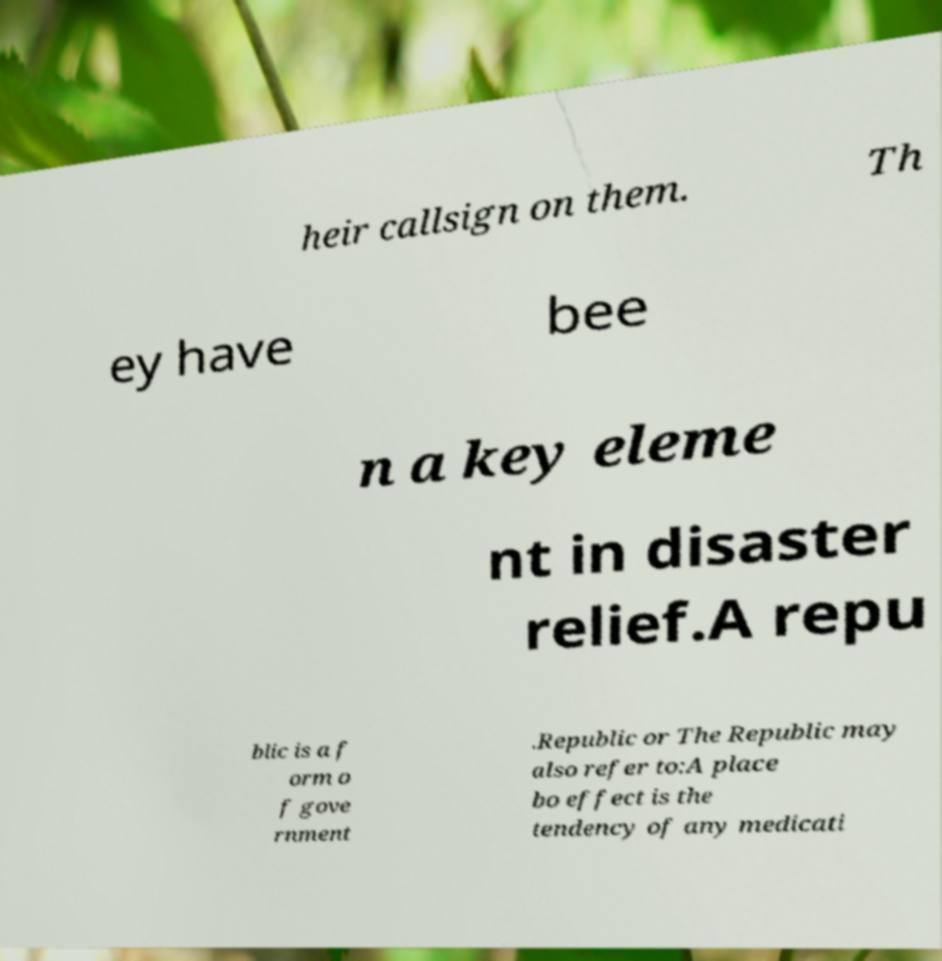Please read and relay the text visible in this image. What does it say? heir callsign on them. Th ey have bee n a key eleme nt in disaster relief.A repu blic is a f orm o f gove rnment .Republic or The Republic may also refer to:A place bo effect is the tendency of any medicati 